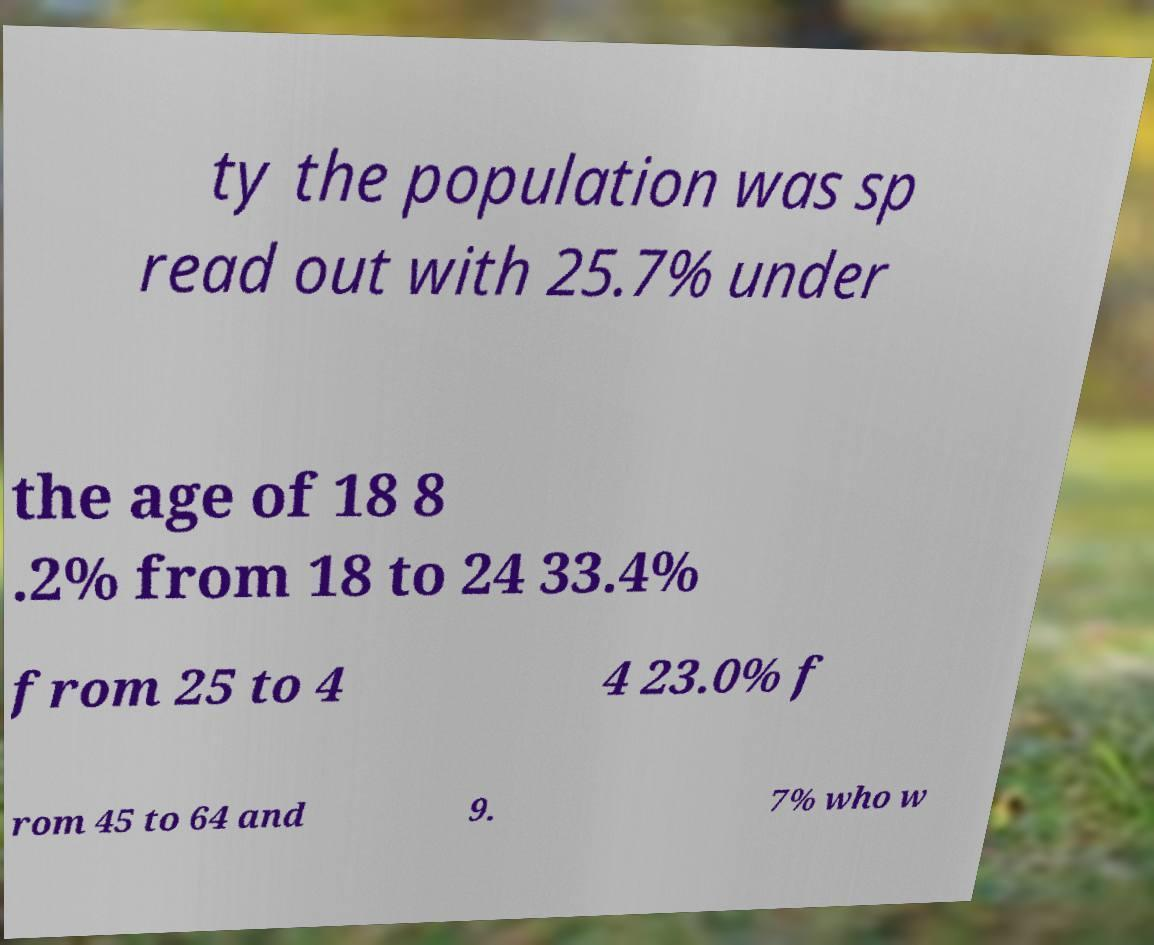Can you accurately transcribe the text from the provided image for me? ty the population was sp read out with 25.7% under the age of 18 8 .2% from 18 to 24 33.4% from 25 to 4 4 23.0% f rom 45 to 64 and 9. 7% who w 